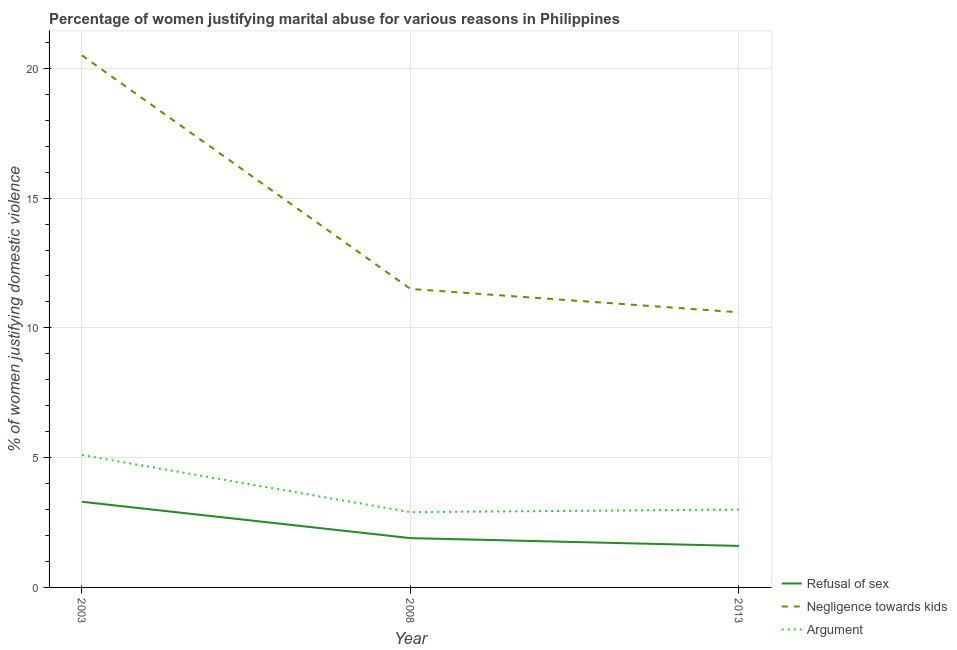How many different coloured lines are there?
Provide a short and direct response. 3. Is the number of lines equal to the number of legend labels?
Offer a very short reply. Yes. Across all years, what is the minimum percentage of women justifying domestic violence due to arguments?
Provide a short and direct response. 2.9. In which year was the percentage of women justifying domestic violence due to negligence towards kids minimum?
Provide a succinct answer. 2013. What is the total percentage of women justifying domestic violence due to arguments in the graph?
Your answer should be compact. 11. What is the difference between the percentage of women justifying domestic violence due to arguments in 2008 and that in 2013?
Give a very brief answer. -0.1. What is the average percentage of women justifying domestic violence due to negligence towards kids per year?
Your answer should be very brief. 14.2. In the year 2008, what is the difference between the percentage of women justifying domestic violence due to arguments and percentage of women justifying domestic violence due to refusal of sex?
Offer a very short reply. 1. Is the percentage of women justifying domestic violence due to refusal of sex in 2008 less than that in 2013?
Ensure brevity in your answer.  No. What is the difference between the highest and the lowest percentage of women justifying domestic violence due to arguments?
Keep it short and to the point. 2.2. Is it the case that in every year, the sum of the percentage of women justifying domestic violence due to refusal of sex and percentage of women justifying domestic violence due to negligence towards kids is greater than the percentage of women justifying domestic violence due to arguments?
Make the answer very short. Yes. Is the percentage of women justifying domestic violence due to refusal of sex strictly greater than the percentage of women justifying domestic violence due to arguments over the years?
Make the answer very short. No. Is the percentage of women justifying domestic violence due to negligence towards kids strictly less than the percentage of women justifying domestic violence due to arguments over the years?
Ensure brevity in your answer.  No. How many years are there in the graph?
Offer a terse response. 3. Does the graph contain any zero values?
Your answer should be compact. No. Does the graph contain grids?
Offer a terse response. Yes. How many legend labels are there?
Your answer should be very brief. 3. What is the title of the graph?
Your answer should be compact. Percentage of women justifying marital abuse for various reasons in Philippines. Does "Transport" appear as one of the legend labels in the graph?
Your answer should be compact. No. What is the label or title of the X-axis?
Your answer should be compact. Year. What is the label or title of the Y-axis?
Provide a succinct answer. % of women justifying domestic violence. What is the % of women justifying domestic violence in Refusal of sex in 2003?
Keep it short and to the point. 3.3. What is the % of women justifying domestic violence in Negligence towards kids in 2003?
Ensure brevity in your answer.  20.5. What is the % of women justifying domestic violence in Refusal of sex in 2008?
Your response must be concise. 1.9. What is the % of women justifying domestic violence of Negligence towards kids in 2013?
Your answer should be compact. 10.6. Across all years, what is the maximum % of women justifying domestic violence in Argument?
Offer a very short reply. 5.1. Across all years, what is the minimum % of women justifying domestic violence of Refusal of sex?
Keep it short and to the point. 1.6. Across all years, what is the minimum % of women justifying domestic violence in Argument?
Provide a short and direct response. 2.9. What is the total % of women justifying domestic violence of Negligence towards kids in the graph?
Offer a terse response. 42.6. What is the total % of women justifying domestic violence of Argument in the graph?
Offer a terse response. 11. What is the difference between the % of women justifying domestic violence in Argument in 2003 and that in 2013?
Offer a very short reply. 2.1. What is the difference between the % of women justifying domestic violence in Refusal of sex in 2008 and that in 2013?
Offer a very short reply. 0.3. What is the difference between the % of women justifying domestic violence of Negligence towards kids in 2008 and that in 2013?
Offer a very short reply. 0.9. What is the difference between the % of women justifying domestic violence of Argument in 2008 and that in 2013?
Give a very brief answer. -0.1. What is the difference between the % of women justifying domestic violence of Refusal of sex in 2003 and the % of women justifying domestic violence of Negligence towards kids in 2008?
Your answer should be compact. -8.2. What is the difference between the % of women justifying domestic violence of Negligence towards kids in 2003 and the % of women justifying domestic violence of Argument in 2008?
Make the answer very short. 17.6. What is the difference between the % of women justifying domestic violence in Refusal of sex in 2008 and the % of women justifying domestic violence in Negligence towards kids in 2013?
Provide a short and direct response. -8.7. What is the difference between the % of women justifying domestic violence of Negligence towards kids in 2008 and the % of women justifying domestic violence of Argument in 2013?
Offer a terse response. 8.5. What is the average % of women justifying domestic violence in Refusal of sex per year?
Offer a terse response. 2.27. What is the average % of women justifying domestic violence in Argument per year?
Give a very brief answer. 3.67. In the year 2003, what is the difference between the % of women justifying domestic violence of Refusal of sex and % of women justifying domestic violence of Negligence towards kids?
Make the answer very short. -17.2. In the year 2003, what is the difference between the % of women justifying domestic violence of Refusal of sex and % of women justifying domestic violence of Argument?
Offer a terse response. -1.8. In the year 2003, what is the difference between the % of women justifying domestic violence in Negligence towards kids and % of women justifying domestic violence in Argument?
Offer a terse response. 15.4. In the year 2008, what is the difference between the % of women justifying domestic violence of Negligence towards kids and % of women justifying domestic violence of Argument?
Your answer should be compact. 8.6. In the year 2013, what is the difference between the % of women justifying domestic violence in Refusal of sex and % of women justifying domestic violence in Negligence towards kids?
Offer a very short reply. -9. What is the ratio of the % of women justifying domestic violence of Refusal of sex in 2003 to that in 2008?
Offer a terse response. 1.74. What is the ratio of the % of women justifying domestic violence of Negligence towards kids in 2003 to that in 2008?
Offer a very short reply. 1.78. What is the ratio of the % of women justifying domestic violence in Argument in 2003 to that in 2008?
Offer a very short reply. 1.76. What is the ratio of the % of women justifying domestic violence of Refusal of sex in 2003 to that in 2013?
Keep it short and to the point. 2.06. What is the ratio of the % of women justifying domestic violence in Negligence towards kids in 2003 to that in 2013?
Your answer should be very brief. 1.93. What is the ratio of the % of women justifying domestic violence of Argument in 2003 to that in 2013?
Provide a succinct answer. 1.7. What is the ratio of the % of women justifying domestic violence in Refusal of sex in 2008 to that in 2013?
Provide a short and direct response. 1.19. What is the ratio of the % of women justifying domestic violence in Negligence towards kids in 2008 to that in 2013?
Make the answer very short. 1.08. What is the ratio of the % of women justifying domestic violence of Argument in 2008 to that in 2013?
Provide a succinct answer. 0.97. What is the difference between the highest and the second highest % of women justifying domestic violence of Refusal of sex?
Your answer should be compact. 1.4. What is the difference between the highest and the second highest % of women justifying domestic violence of Negligence towards kids?
Make the answer very short. 9. What is the difference between the highest and the second highest % of women justifying domestic violence of Argument?
Ensure brevity in your answer.  2.1. What is the difference between the highest and the lowest % of women justifying domestic violence of Negligence towards kids?
Offer a very short reply. 9.9. 